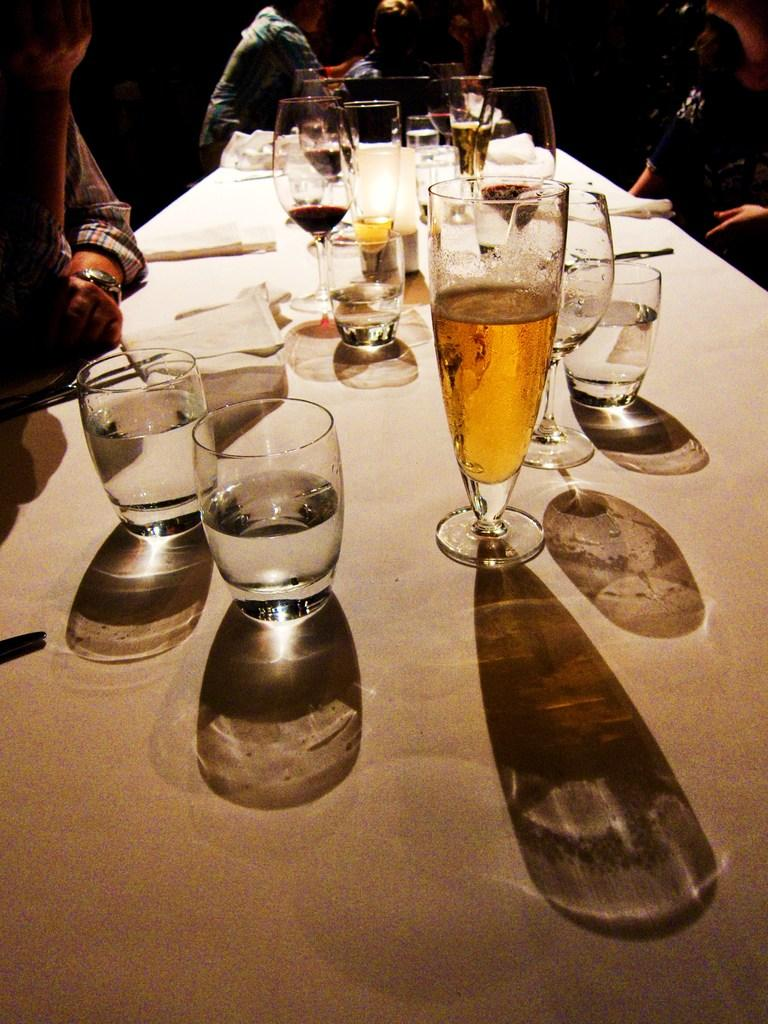What is happening in the image? There are persons in front of a table. What can be seen on the table? There are glasses with drinks and tissue papers on the table. Are there any utensils visible in the image? Yes, there is a spoon visible in the image. What type of calculator is being used by the persons in the image? There is no calculator present in the image. Are the persons wearing masks in the image? There is no mention of masks in the image. --- Facts: 1. There is a person holding a book. 2. The book has a blue cover. 3. The person is sitting on a chair. 4. There is a table next to the chair. 5. The table has a lamp on it. Absurd Topics: bicycle, parrot, ocean Conversation: What is the person holding in the image? The person is holding a book. What color is the book's cover? The book has a blue cover. What is the person sitting on? The person is sitting on a chair. What can be seen on the table next to the chair? There is a lamp on the table. Reasoning: Let's think step by step in order to produce the conversation. We start by identifying the main subject in the image, which is the person holding a book. Next, we describe specific features of the book, such as the color of its cover. Then, we observe the actions of the person in the image, noting that they are sitting on a chair. Finally, we describe the objects on the table next to the chair, which is a lamp. Absurd Question/Answer: Can you see a bicycle in the image? No, there is no bicycle present in the image. 